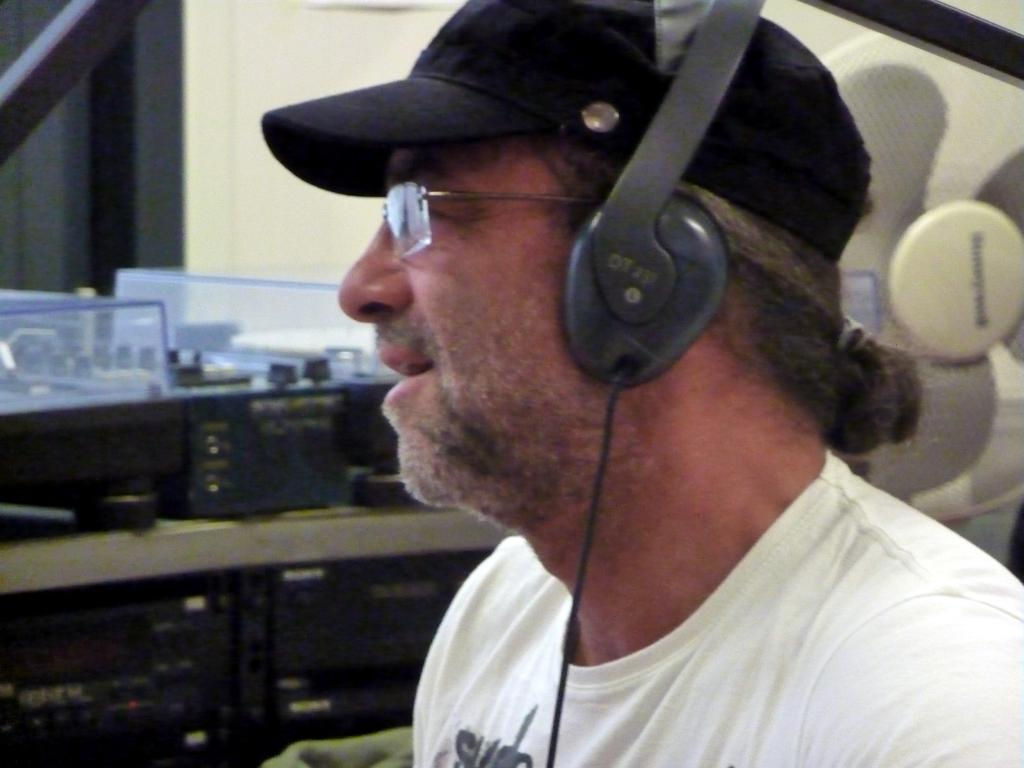What is the main subject of the image? There is a person in the image. What is the person wearing on their upper body? The person is wearing a white T-shirt. What is the person wearing on their head? The person is wearing a headset. Can you describe the background of the image? There are other objects in the background of the image. What type of rock can be seen in the person's sock in the image? There is no rock or sock present in the image; the person is wearing a headset and a white T-shirt. 